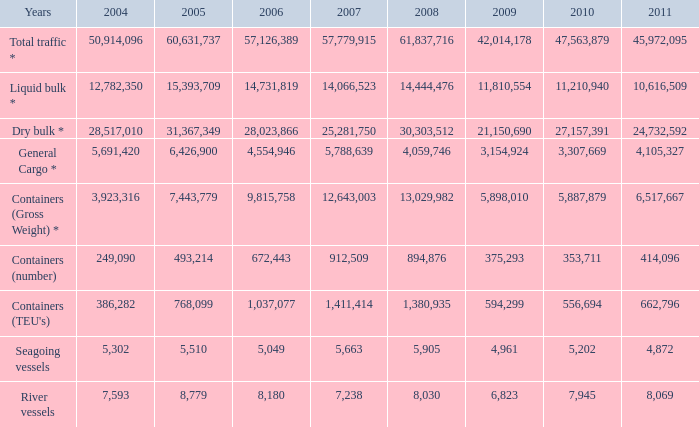What is the lowest value in 2007 when 2009 is 42,014,178 and 2008 is over 61,837,716? None. 